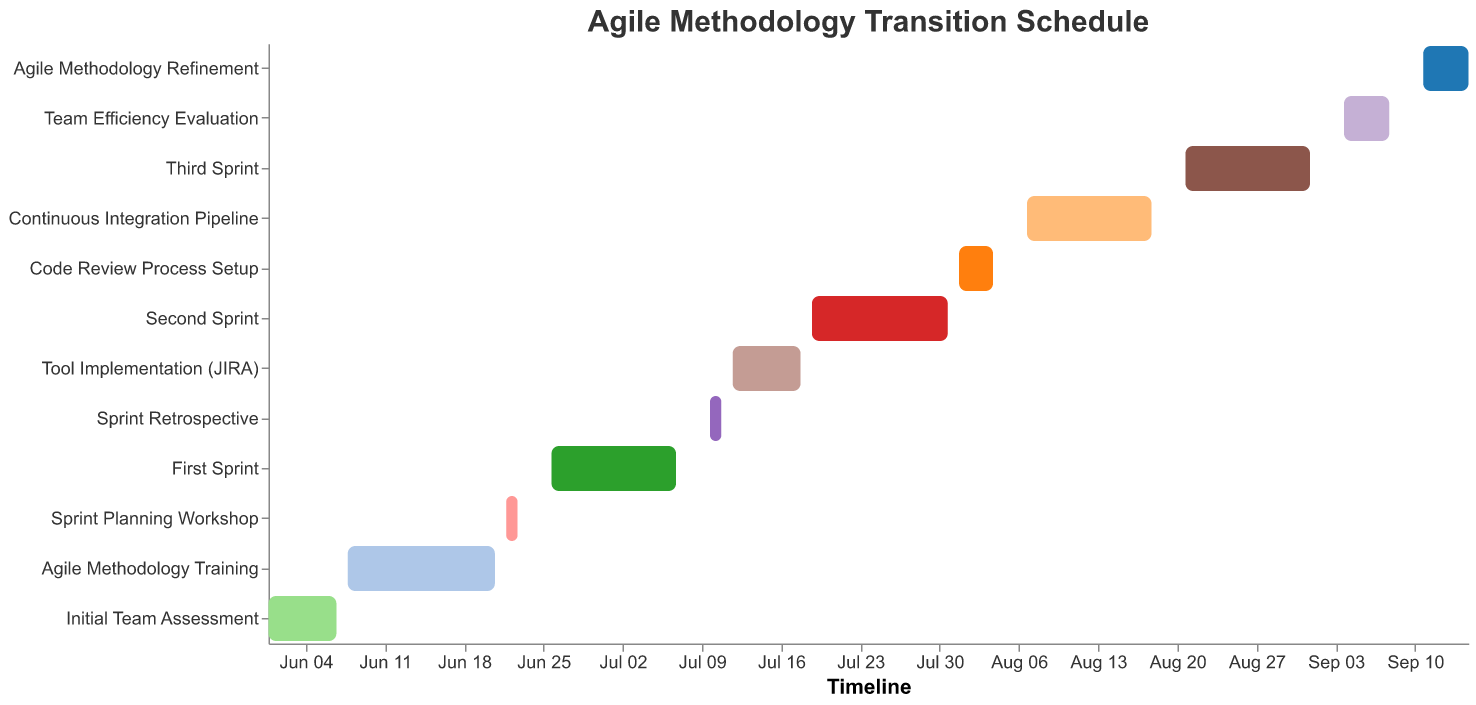What is the first task in the agile methodology transition schedule? The first task listed in the Gantt Chart is "Initial Team Assessment” which starts on June 1, 2023.
Answer: Initial Team Assessment How long does the Agile Methodology Training last? The Agile Methodology Training starts on June 8, 2023, and ends on June 21, 2023. The duration is 14 days as specified.
Answer: 14 days Which task has the shortest duration and how many days is it? By examining the Gantt Chart, the "Sprint Planning Workshop" and "Sprint Retrospective" have the shortest duration of 2 days each.
Answer: Sprint Planning Workshop and Sprint Retrospective, 2 days What task immediately follows the First Sprint? Referring to the chronological order and dates, the task that follows the "First Sprint" is "Sprint Retrospective," which starts on July 10, 2023.
Answer: Sprint Retrospective How many tasks are scheduled for the month of August? The Gantt Chart shows four tasks scheduled for August: "Code Review Process Setup," "Continuous Integration Pipeline," "Third Sprint," and "Team Efficiency Evaluation."
Answer: 4 tasks What is the total duration of all sprints combined? The durations of the First, Second, and Third Sprints are 12, 13, and 12 days respectively. Adding these together gives 12 + 13 + 12 = 37 days.
Answer: 37 days Which task has the same duration as the Agile Methodology Refinement and what is its duration? Both "Team Efficiency Evaluation" and "Agile Methodology Refinement" have the same duration of 5 days.
Answer: Team Efficiency Evaluation and Agile Methodology Refinement, 5 days What is the color used to represent the Tool Implementation (JIRA)? The color for each task varies and is assigned automatically by the visualization library. Looking at the legend of the Gantt Chart will display the corresponding color for "Tool Implementation (JIRA)."
Answer: [Refer to the chart for the exact color] What is the combined duration of the Agile Methodology Training and Continuous Integration Pipeline? The Agile Methodology Training duration is 14 days, and the Continuous Integration Pipeline duration is 12 days. Adding these together gives 14 + 12 = 26 days.
Answer: 26 days Is there any overlap between the First Sprint and the Sprint Planning Workshop? By examining the dates, the First Sprint starts on June 26, 2023, and the Sprint Planning Workshop ends on June 23, 2023. There is no overlap between these two tasks.
Answer: No 